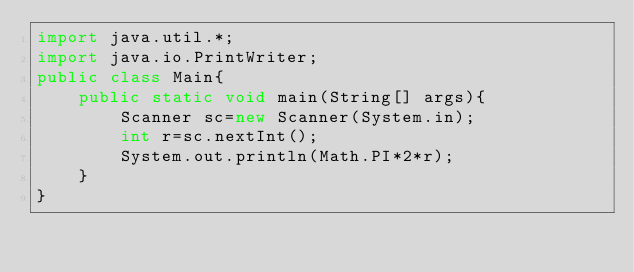Convert code to text. <code><loc_0><loc_0><loc_500><loc_500><_Java_>import java.util.*;
import java.io.PrintWriter;
public class Main{
	public static void main(String[] args){
		Scanner sc=new Scanner(System.in);
		int r=sc.nextInt();
		System.out.println(Math.PI*2*r);
	}
}
</code> 